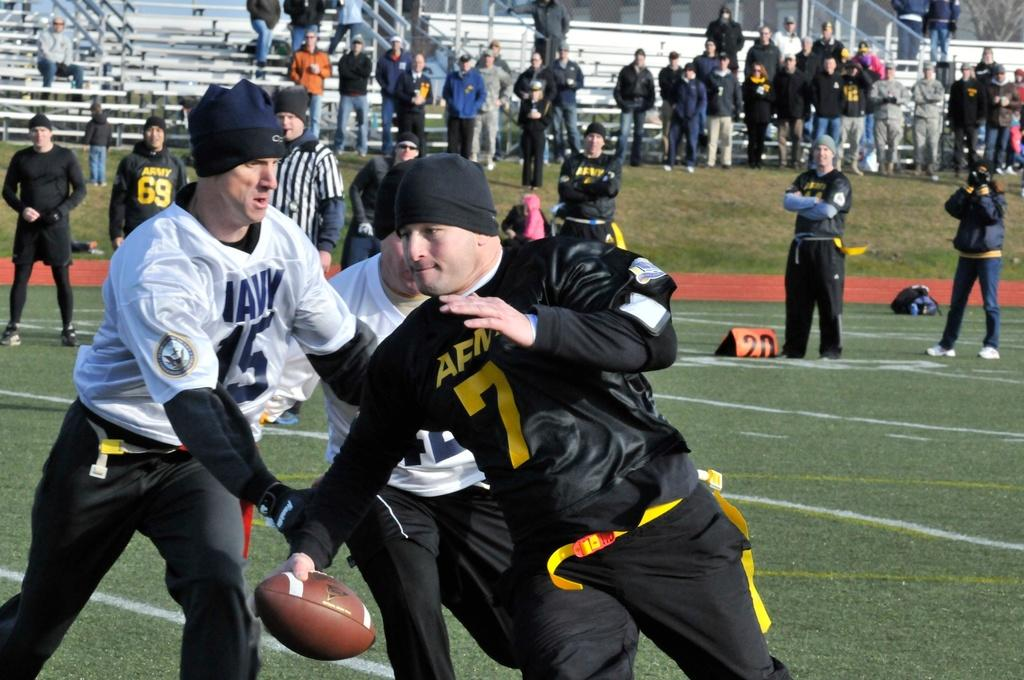What is happening in the image involving a group of people? There is a group of people in the image, and some of them are playing a game in the ground while others are standing outside the ground. Can you describe the activities of the people in the image? Some people are playing a game, which suggests they are engaged in a sport or recreational activity, while others are observing or waiting nearby. How many people are involved in the game? The number of people playing the game is not specified, but it is clear that there are at least two groups of people in the image. What type of crown is being worn by the person in the rainstorm in the image? There is no person wearing a crown in a rainstorm in the image; the image only shows a group of people playing a game and others standing outside the ground. 